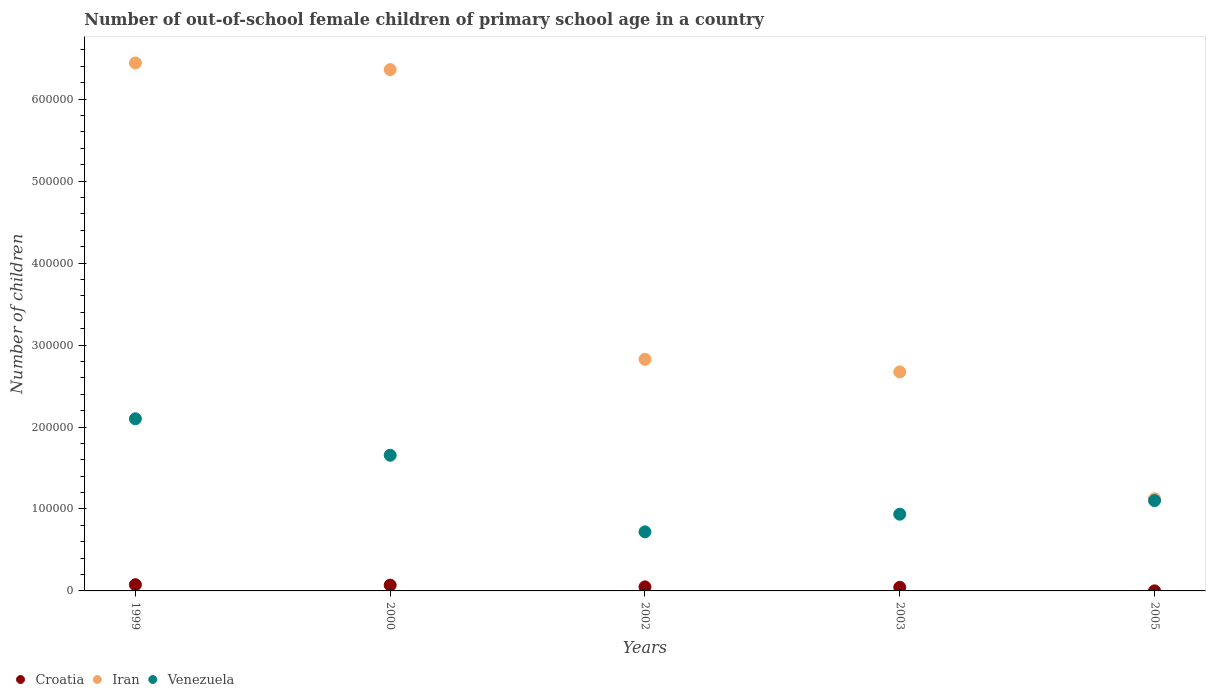How many different coloured dotlines are there?
Your answer should be very brief. 3. Is the number of dotlines equal to the number of legend labels?
Offer a terse response. Yes. What is the number of out-of-school female children in Iran in 2003?
Provide a succinct answer. 2.67e+05. Across all years, what is the maximum number of out-of-school female children in Venezuela?
Give a very brief answer. 2.10e+05. Across all years, what is the minimum number of out-of-school female children in Iran?
Give a very brief answer. 1.12e+05. In which year was the number of out-of-school female children in Venezuela minimum?
Keep it short and to the point. 2002. What is the total number of out-of-school female children in Venezuela in the graph?
Your answer should be compact. 6.51e+05. What is the difference between the number of out-of-school female children in Venezuela in 2002 and that in 2003?
Offer a very short reply. -2.15e+04. What is the difference between the number of out-of-school female children in Croatia in 2002 and the number of out-of-school female children in Iran in 2000?
Offer a terse response. -6.31e+05. What is the average number of out-of-school female children in Croatia per year?
Offer a very short reply. 4798.8. In the year 1999, what is the difference between the number of out-of-school female children in Croatia and number of out-of-school female children in Venezuela?
Provide a succinct answer. -2.02e+05. What is the ratio of the number of out-of-school female children in Croatia in 2000 to that in 2005?
Make the answer very short. 92.8. Is the number of out-of-school female children in Venezuela in 1999 less than that in 2000?
Ensure brevity in your answer.  No. What is the difference between the highest and the second highest number of out-of-school female children in Iran?
Offer a terse response. 8106. What is the difference between the highest and the lowest number of out-of-school female children in Venezuela?
Offer a terse response. 1.38e+05. In how many years, is the number of out-of-school female children in Croatia greater than the average number of out-of-school female children in Croatia taken over all years?
Ensure brevity in your answer.  3. Is the sum of the number of out-of-school female children in Iran in 2002 and 2003 greater than the maximum number of out-of-school female children in Venezuela across all years?
Your answer should be compact. Yes. Is it the case that in every year, the sum of the number of out-of-school female children in Croatia and number of out-of-school female children in Iran  is greater than the number of out-of-school female children in Venezuela?
Offer a terse response. Yes. Is the number of out-of-school female children in Croatia strictly greater than the number of out-of-school female children in Iran over the years?
Make the answer very short. No. How many dotlines are there?
Provide a succinct answer. 3. Does the graph contain grids?
Your answer should be very brief. No. Where does the legend appear in the graph?
Make the answer very short. Bottom left. How many legend labels are there?
Keep it short and to the point. 3. How are the legend labels stacked?
Offer a terse response. Horizontal. What is the title of the graph?
Offer a very short reply. Number of out-of-school female children of primary school age in a country. Does "South Asia" appear as one of the legend labels in the graph?
Make the answer very short. No. What is the label or title of the Y-axis?
Provide a short and direct response. Number of children. What is the Number of children in Croatia in 1999?
Your response must be concise. 7567. What is the Number of children of Iran in 1999?
Your answer should be very brief. 6.44e+05. What is the Number of children in Venezuela in 1999?
Offer a terse response. 2.10e+05. What is the Number of children in Croatia in 2000?
Make the answer very short. 7053. What is the Number of children in Iran in 2000?
Your response must be concise. 6.36e+05. What is the Number of children in Venezuela in 2000?
Make the answer very short. 1.66e+05. What is the Number of children of Croatia in 2002?
Your answer should be compact. 4923. What is the Number of children of Iran in 2002?
Your answer should be compact. 2.83e+05. What is the Number of children in Venezuela in 2002?
Give a very brief answer. 7.21e+04. What is the Number of children of Croatia in 2003?
Offer a terse response. 4375. What is the Number of children in Iran in 2003?
Make the answer very short. 2.67e+05. What is the Number of children of Venezuela in 2003?
Your response must be concise. 9.36e+04. What is the Number of children of Iran in 2005?
Provide a short and direct response. 1.12e+05. What is the Number of children in Venezuela in 2005?
Your answer should be compact. 1.10e+05. Across all years, what is the maximum Number of children of Croatia?
Provide a short and direct response. 7567. Across all years, what is the maximum Number of children of Iran?
Provide a short and direct response. 6.44e+05. Across all years, what is the maximum Number of children of Venezuela?
Your answer should be compact. 2.10e+05. Across all years, what is the minimum Number of children in Iran?
Give a very brief answer. 1.12e+05. Across all years, what is the minimum Number of children in Venezuela?
Your answer should be very brief. 7.21e+04. What is the total Number of children in Croatia in the graph?
Offer a terse response. 2.40e+04. What is the total Number of children in Iran in the graph?
Provide a short and direct response. 1.94e+06. What is the total Number of children in Venezuela in the graph?
Give a very brief answer. 6.51e+05. What is the difference between the Number of children in Croatia in 1999 and that in 2000?
Keep it short and to the point. 514. What is the difference between the Number of children of Iran in 1999 and that in 2000?
Keep it short and to the point. 8106. What is the difference between the Number of children in Venezuela in 1999 and that in 2000?
Provide a short and direct response. 4.45e+04. What is the difference between the Number of children in Croatia in 1999 and that in 2002?
Provide a succinct answer. 2644. What is the difference between the Number of children of Iran in 1999 and that in 2002?
Provide a succinct answer. 3.62e+05. What is the difference between the Number of children in Venezuela in 1999 and that in 2002?
Your answer should be very brief. 1.38e+05. What is the difference between the Number of children of Croatia in 1999 and that in 2003?
Offer a terse response. 3192. What is the difference between the Number of children in Iran in 1999 and that in 2003?
Give a very brief answer. 3.77e+05. What is the difference between the Number of children of Venezuela in 1999 and that in 2003?
Your answer should be compact. 1.16e+05. What is the difference between the Number of children of Croatia in 1999 and that in 2005?
Offer a terse response. 7491. What is the difference between the Number of children of Iran in 1999 and that in 2005?
Your answer should be very brief. 5.32e+05. What is the difference between the Number of children of Venezuela in 1999 and that in 2005?
Your answer should be very brief. 9.99e+04. What is the difference between the Number of children of Croatia in 2000 and that in 2002?
Your answer should be very brief. 2130. What is the difference between the Number of children in Iran in 2000 and that in 2002?
Your answer should be very brief. 3.53e+05. What is the difference between the Number of children in Venezuela in 2000 and that in 2002?
Offer a terse response. 9.35e+04. What is the difference between the Number of children of Croatia in 2000 and that in 2003?
Your answer should be very brief. 2678. What is the difference between the Number of children in Iran in 2000 and that in 2003?
Ensure brevity in your answer.  3.69e+05. What is the difference between the Number of children in Venezuela in 2000 and that in 2003?
Provide a succinct answer. 7.19e+04. What is the difference between the Number of children of Croatia in 2000 and that in 2005?
Your answer should be very brief. 6977. What is the difference between the Number of children in Iran in 2000 and that in 2005?
Offer a very short reply. 5.24e+05. What is the difference between the Number of children of Venezuela in 2000 and that in 2005?
Make the answer very short. 5.54e+04. What is the difference between the Number of children in Croatia in 2002 and that in 2003?
Make the answer very short. 548. What is the difference between the Number of children in Iran in 2002 and that in 2003?
Provide a succinct answer. 1.54e+04. What is the difference between the Number of children of Venezuela in 2002 and that in 2003?
Your response must be concise. -2.15e+04. What is the difference between the Number of children of Croatia in 2002 and that in 2005?
Give a very brief answer. 4847. What is the difference between the Number of children of Iran in 2002 and that in 2005?
Provide a short and direct response. 1.70e+05. What is the difference between the Number of children of Venezuela in 2002 and that in 2005?
Offer a terse response. -3.81e+04. What is the difference between the Number of children of Croatia in 2003 and that in 2005?
Your response must be concise. 4299. What is the difference between the Number of children in Iran in 2003 and that in 2005?
Give a very brief answer. 1.55e+05. What is the difference between the Number of children in Venezuela in 2003 and that in 2005?
Ensure brevity in your answer.  -1.66e+04. What is the difference between the Number of children of Croatia in 1999 and the Number of children of Iran in 2000?
Your answer should be compact. -6.28e+05. What is the difference between the Number of children of Croatia in 1999 and the Number of children of Venezuela in 2000?
Provide a succinct answer. -1.58e+05. What is the difference between the Number of children in Iran in 1999 and the Number of children in Venezuela in 2000?
Your answer should be very brief. 4.79e+05. What is the difference between the Number of children of Croatia in 1999 and the Number of children of Iran in 2002?
Provide a short and direct response. -2.75e+05. What is the difference between the Number of children of Croatia in 1999 and the Number of children of Venezuela in 2002?
Give a very brief answer. -6.45e+04. What is the difference between the Number of children in Iran in 1999 and the Number of children in Venezuela in 2002?
Make the answer very short. 5.72e+05. What is the difference between the Number of children of Croatia in 1999 and the Number of children of Iran in 2003?
Your answer should be compact. -2.60e+05. What is the difference between the Number of children of Croatia in 1999 and the Number of children of Venezuela in 2003?
Ensure brevity in your answer.  -8.60e+04. What is the difference between the Number of children in Iran in 1999 and the Number of children in Venezuela in 2003?
Ensure brevity in your answer.  5.51e+05. What is the difference between the Number of children of Croatia in 1999 and the Number of children of Iran in 2005?
Your response must be concise. -1.05e+05. What is the difference between the Number of children in Croatia in 1999 and the Number of children in Venezuela in 2005?
Your answer should be very brief. -1.03e+05. What is the difference between the Number of children of Iran in 1999 and the Number of children of Venezuela in 2005?
Give a very brief answer. 5.34e+05. What is the difference between the Number of children in Croatia in 2000 and the Number of children in Iran in 2002?
Provide a short and direct response. -2.76e+05. What is the difference between the Number of children in Croatia in 2000 and the Number of children in Venezuela in 2002?
Offer a terse response. -6.50e+04. What is the difference between the Number of children in Iran in 2000 and the Number of children in Venezuela in 2002?
Offer a terse response. 5.64e+05. What is the difference between the Number of children in Croatia in 2000 and the Number of children in Iran in 2003?
Your response must be concise. -2.60e+05. What is the difference between the Number of children in Croatia in 2000 and the Number of children in Venezuela in 2003?
Ensure brevity in your answer.  -8.65e+04. What is the difference between the Number of children of Iran in 2000 and the Number of children of Venezuela in 2003?
Your response must be concise. 5.42e+05. What is the difference between the Number of children of Croatia in 2000 and the Number of children of Iran in 2005?
Provide a short and direct response. -1.05e+05. What is the difference between the Number of children in Croatia in 2000 and the Number of children in Venezuela in 2005?
Make the answer very short. -1.03e+05. What is the difference between the Number of children in Iran in 2000 and the Number of children in Venezuela in 2005?
Give a very brief answer. 5.26e+05. What is the difference between the Number of children of Croatia in 2002 and the Number of children of Iran in 2003?
Offer a very short reply. -2.62e+05. What is the difference between the Number of children in Croatia in 2002 and the Number of children in Venezuela in 2003?
Your answer should be compact. -8.87e+04. What is the difference between the Number of children in Iran in 2002 and the Number of children in Venezuela in 2003?
Your answer should be very brief. 1.89e+05. What is the difference between the Number of children of Croatia in 2002 and the Number of children of Iran in 2005?
Your answer should be very brief. -1.07e+05. What is the difference between the Number of children in Croatia in 2002 and the Number of children in Venezuela in 2005?
Give a very brief answer. -1.05e+05. What is the difference between the Number of children in Iran in 2002 and the Number of children in Venezuela in 2005?
Offer a very short reply. 1.72e+05. What is the difference between the Number of children in Croatia in 2003 and the Number of children in Iran in 2005?
Offer a very short reply. -1.08e+05. What is the difference between the Number of children in Croatia in 2003 and the Number of children in Venezuela in 2005?
Provide a succinct answer. -1.06e+05. What is the difference between the Number of children of Iran in 2003 and the Number of children of Venezuela in 2005?
Ensure brevity in your answer.  1.57e+05. What is the average Number of children in Croatia per year?
Your answer should be very brief. 4798.8. What is the average Number of children of Iran per year?
Your response must be concise. 3.88e+05. What is the average Number of children in Venezuela per year?
Your response must be concise. 1.30e+05. In the year 1999, what is the difference between the Number of children of Croatia and Number of children of Iran?
Provide a succinct answer. -6.37e+05. In the year 1999, what is the difference between the Number of children in Croatia and Number of children in Venezuela?
Offer a terse response. -2.02e+05. In the year 1999, what is the difference between the Number of children in Iran and Number of children in Venezuela?
Offer a very short reply. 4.34e+05. In the year 2000, what is the difference between the Number of children of Croatia and Number of children of Iran?
Your answer should be very brief. -6.29e+05. In the year 2000, what is the difference between the Number of children in Croatia and Number of children in Venezuela?
Offer a terse response. -1.58e+05. In the year 2000, what is the difference between the Number of children of Iran and Number of children of Venezuela?
Your answer should be very brief. 4.70e+05. In the year 2002, what is the difference between the Number of children of Croatia and Number of children of Iran?
Offer a terse response. -2.78e+05. In the year 2002, what is the difference between the Number of children in Croatia and Number of children in Venezuela?
Ensure brevity in your answer.  -6.72e+04. In the year 2002, what is the difference between the Number of children of Iran and Number of children of Venezuela?
Provide a short and direct response. 2.10e+05. In the year 2003, what is the difference between the Number of children in Croatia and Number of children in Iran?
Your response must be concise. -2.63e+05. In the year 2003, what is the difference between the Number of children in Croatia and Number of children in Venezuela?
Give a very brief answer. -8.92e+04. In the year 2003, what is the difference between the Number of children of Iran and Number of children of Venezuela?
Keep it short and to the point. 1.74e+05. In the year 2005, what is the difference between the Number of children of Croatia and Number of children of Iran?
Keep it short and to the point. -1.12e+05. In the year 2005, what is the difference between the Number of children in Croatia and Number of children in Venezuela?
Your answer should be compact. -1.10e+05. In the year 2005, what is the difference between the Number of children of Iran and Number of children of Venezuela?
Keep it short and to the point. 2223. What is the ratio of the Number of children of Croatia in 1999 to that in 2000?
Keep it short and to the point. 1.07. What is the ratio of the Number of children of Iran in 1999 to that in 2000?
Offer a terse response. 1.01. What is the ratio of the Number of children of Venezuela in 1999 to that in 2000?
Offer a very short reply. 1.27. What is the ratio of the Number of children of Croatia in 1999 to that in 2002?
Make the answer very short. 1.54. What is the ratio of the Number of children in Iran in 1999 to that in 2002?
Offer a terse response. 2.28. What is the ratio of the Number of children in Venezuela in 1999 to that in 2002?
Offer a terse response. 2.91. What is the ratio of the Number of children of Croatia in 1999 to that in 2003?
Make the answer very short. 1.73. What is the ratio of the Number of children in Iran in 1999 to that in 2003?
Make the answer very short. 2.41. What is the ratio of the Number of children in Venezuela in 1999 to that in 2003?
Give a very brief answer. 2.24. What is the ratio of the Number of children of Croatia in 1999 to that in 2005?
Make the answer very short. 99.57. What is the ratio of the Number of children in Iran in 1999 to that in 2005?
Provide a succinct answer. 5.73. What is the ratio of the Number of children of Venezuela in 1999 to that in 2005?
Offer a very short reply. 1.91. What is the ratio of the Number of children of Croatia in 2000 to that in 2002?
Your response must be concise. 1.43. What is the ratio of the Number of children in Iran in 2000 to that in 2002?
Make the answer very short. 2.25. What is the ratio of the Number of children of Venezuela in 2000 to that in 2002?
Offer a terse response. 2.3. What is the ratio of the Number of children of Croatia in 2000 to that in 2003?
Your answer should be compact. 1.61. What is the ratio of the Number of children in Iran in 2000 to that in 2003?
Offer a very short reply. 2.38. What is the ratio of the Number of children of Venezuela in 2000 to that in 2003?
Your response must be concise. 1.77. What is the ratio of the Number of children in Croatia in 2000 to that in 2005?
Make the answer very short. 92.8. What is the ratio of the Number of children in Iran in 2000 to that in 2005?
Ensure brevity in your answer.  5.66. What is the ratio of the Number of children in Venezuela in 2000 to that in 2005?
Give a very brief answer. 1.5. What is the ratio of the Number of children in Croatia in 2002 to that in 2003?
Make the answer very short. 1.13. What is the ratio of the Number of children of Iran in 2002 to that in 2003?
Give a very brief answer. 1.06. What is the ratio of the Number of children of Venezuela in 2002 to that in 2003?
Provide a short and direct response. 0.77. What is the ratio of the Number of children of Croatia in 2002 to that in 2005?
Give a very brief answer. 64.78. What is the ratio of the Number of children in Iran in 2002 to that in 2005?
Provide a short and direct response. 2.51. What is the ratio of the Number of children in Venezuela in 2002 to that in 2005?
Make the answer very short. 0.65. What is the ratio of the Number of children of Croatia in 2003 to that in 2005?
Keep it short and to the point. 57.57. What is the ratio of the Number of children in Iran in 2003 to that in 2005?
Offer a very short reply. 2.38. What is the ratio of the Number of children of Venezuela in 2003 to that in 2005?
Provide a succinct answer. 0.85. What is the difference between the highest and the second highest Number of children of Croatia?
Your answer should be very brief. 514. What is the difference between the highest and the second highest Number of children in Iran?
Your response must be concise. 8106. What is the difference between the highest and the second highest Number of children of Venezuela?
Offer a very short reply. 4.45e+04. What is the difference between the highest and the lowest Number of children of Croatia?
Your response must be concise. 7491. What is the difference between the highest and the lowest Number of children of Iran?
Offer a terse response. 5.32e+05. What is the difference between the highest and the lowest Number of children of Venezuela?
Keep it short and to the point. 1.38e+05. 